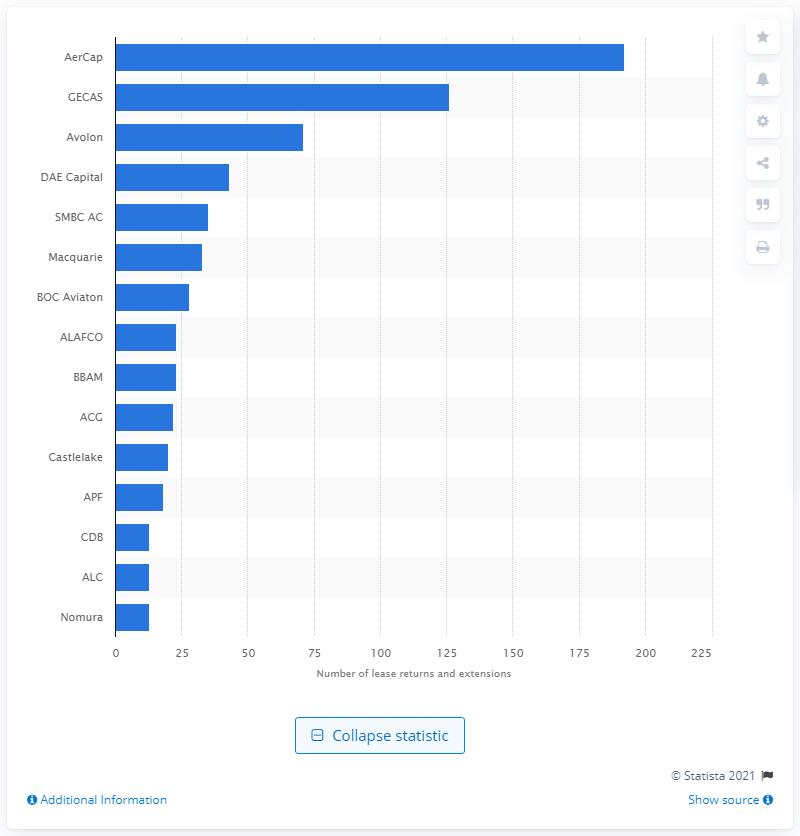Identify some key points in this picture. In 2018, a total of 192 aircraft were expected to enter the "lease end" phase. 